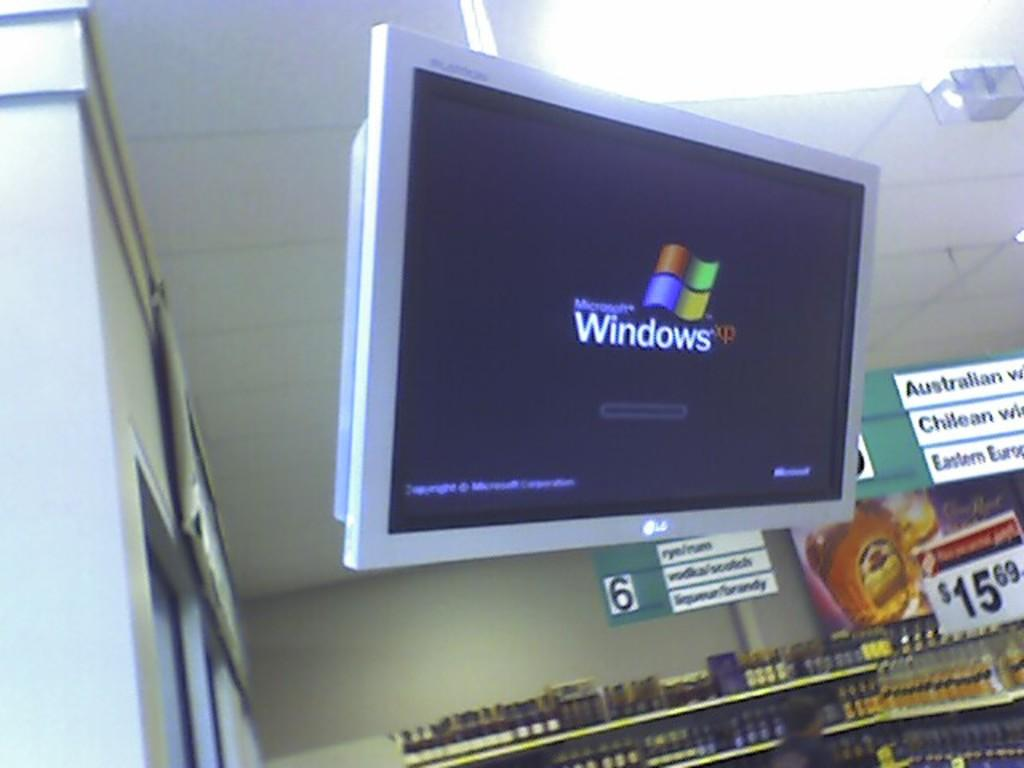<image>
Give a short and clear explanation of the subsequent image. A lg branded television screen with the windows xp boot up screen being displayed. 